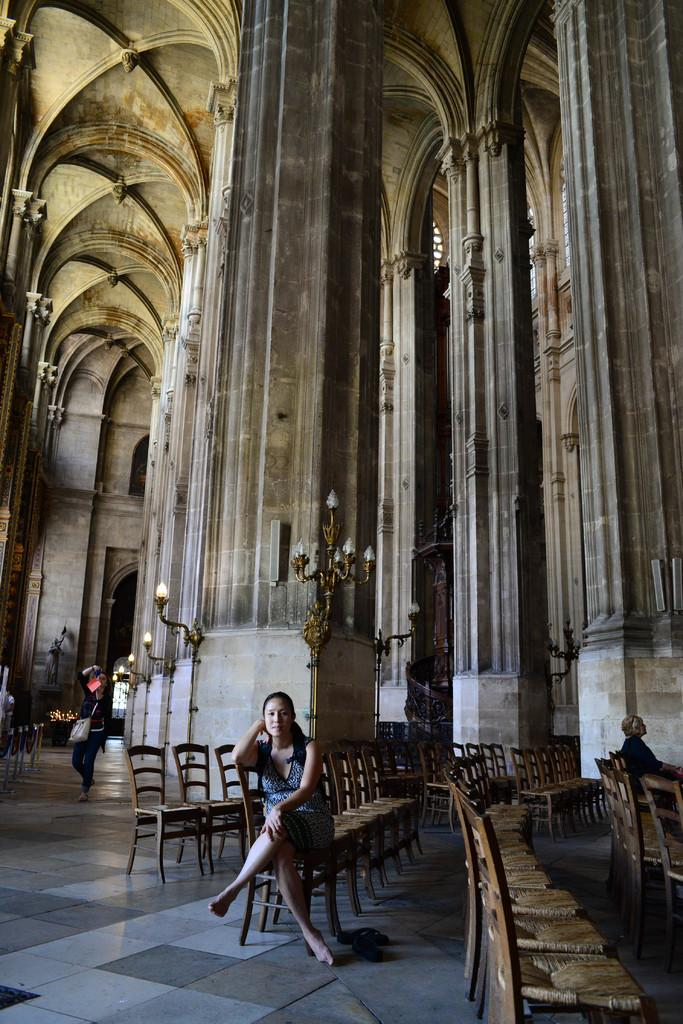Who is the main subject in the image? There is a woman in the image. What is the woman doing in the image? The woman is sitting on a chair. What can be seen below the woman in the image? The floor is visible in the image. What is visible behind the woman in the image? There is a wall and lights in the background of the image. What type of stick can be seen in the woman's hand in the image? There is no stick present in the woman's hand or in the image. 